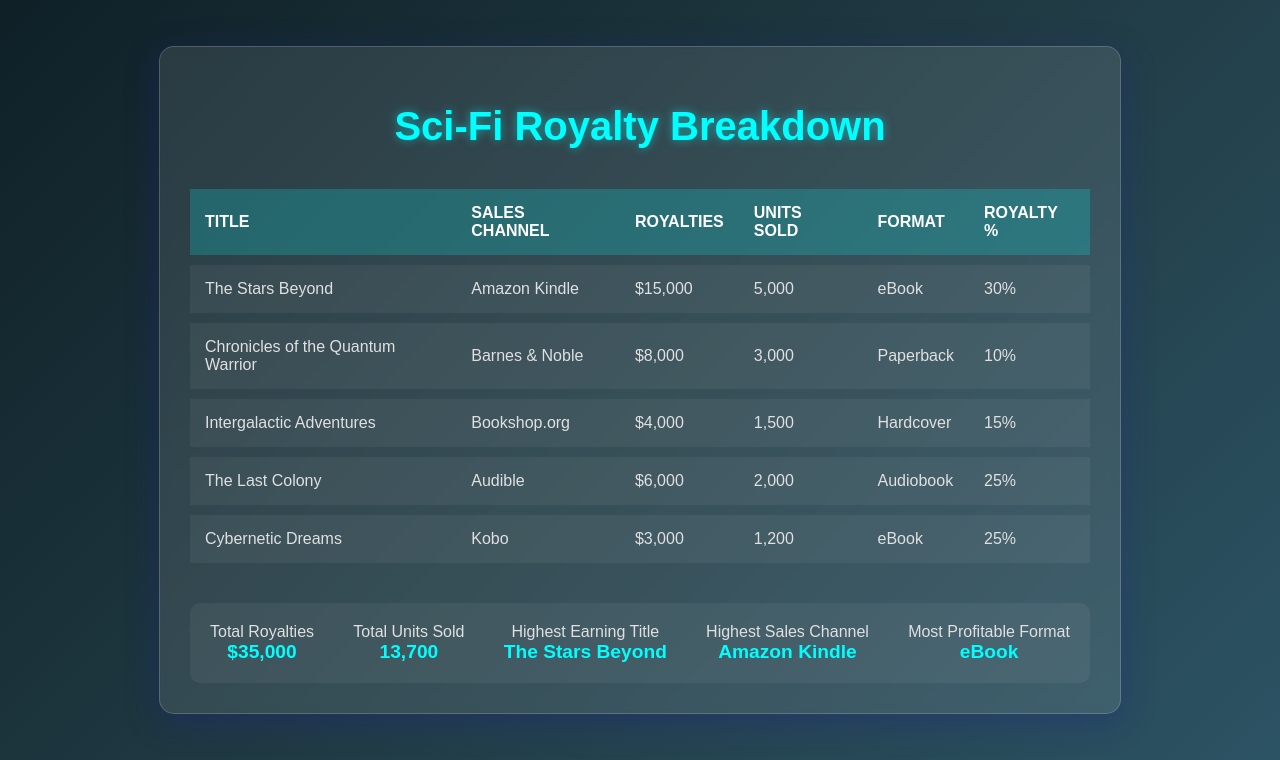What is the total royalties received? The total royalties are summarized at the bottom of the document, which states a total of $35,000.
Answer: $35,000 Which title had the highest earnings? The title with the highest earnings is specified in the summary section of the document as "The Stars Beyond".
Answer: The Stars Beyond What is the sales channel with the highest revenue? The highest earning sales channel is indicated as "Amazon Kindle" in the summary section of the document.
Answer: Amazon Kindle How many units were sold in total? The total units sold are provided in the summary section, amounting to 13,700.
Answer: 13,700 What royalty percentage does "Chronicles of the Quantum Warrior" have? The royalty percentage for that title is listed in the documentation, providing a specific percentage of 10%.
Answer: 10% Which format was the most profitable? The format considered to be the most profitable is stated in the summary as "eBook".
Answer: eBook How much did "Cybernetic Dreams" earn in royalties? The document shows that "Cybernetic Dreams" earned $3,000 in royalties.
Answer: $3,000 How many units of "Intergalactic Adventures" were sold? The number of units sold for "Intergalactic Adventures" is stated in the document as 1,500.
Answer: 1,500 What sales channel sold "The Last Colony"? The sales channel for "The Last Colony" is identified in the table as "Audible".
Answer: Audible 